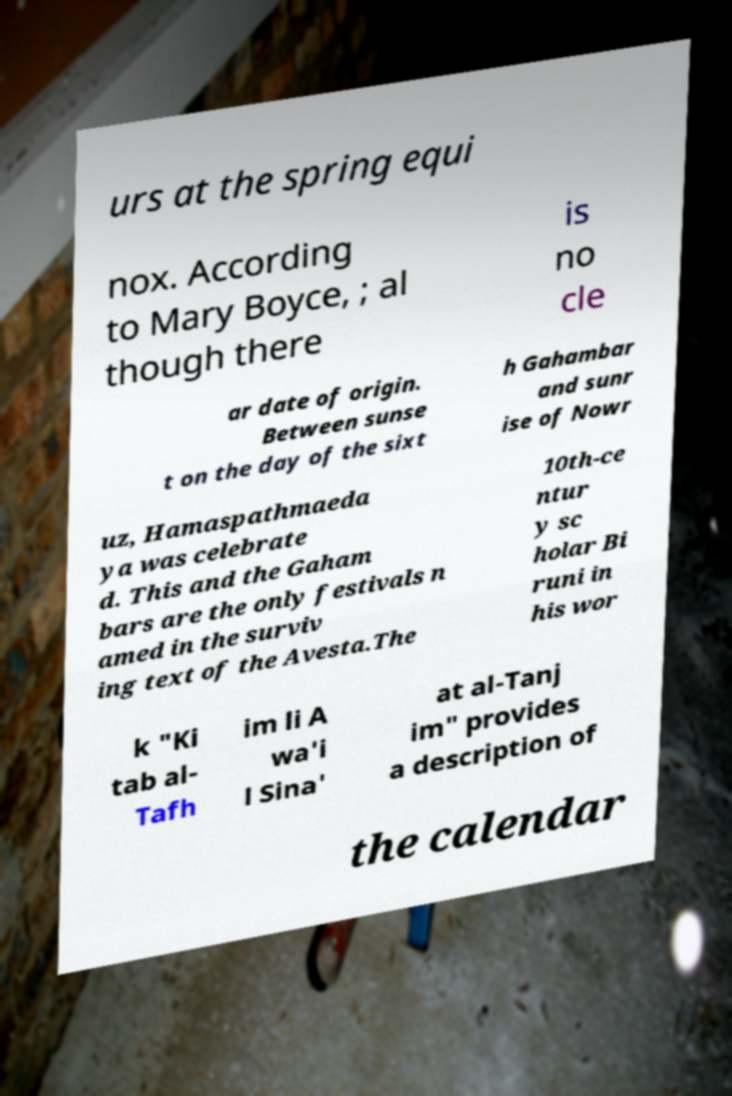Please read and relay the text visible in this image. What does it say? urs at the spring equi nox. According to Mary Boyce, ; al though there is no cle ar date of origin. Between sunse t on the day of the sixt h Gahambar and sunr ise of Nowr uz, Hamaspathmaeda ya was celebrate d. This and the Gaham bars are the only festivals n amed in the surviv ing text of the Avesta.The 10th-ce ntur y sc holar Bi runi in his wor k "Ki tab al- Tafh im li A wa'i l Sina' at al-Tanj im" provides a description of the calendar 